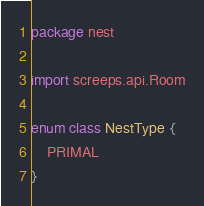<code> <loc_0><loc_0><loc_500><loc_500><_Kotlin_>package nest

import screeps.api.Room

enum class NestType {
    PRIMAL
}
</code> 